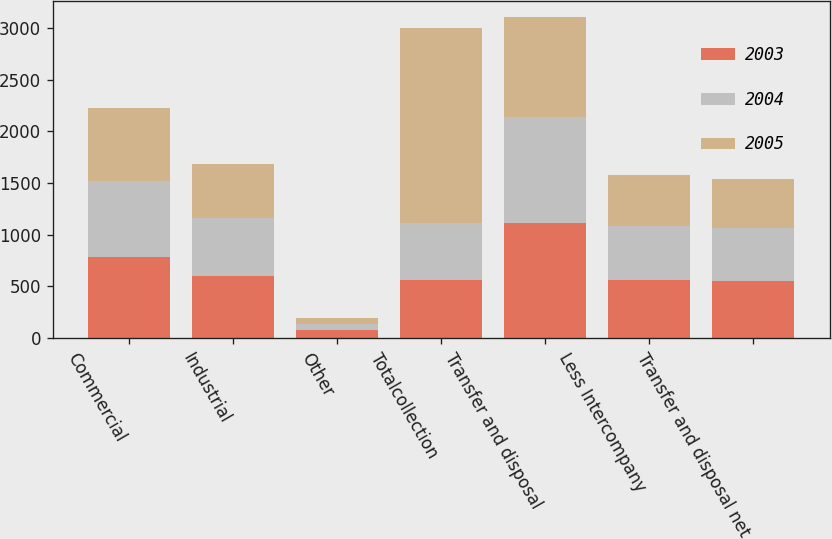Convert chart to OTSL. <chart><loc_0><loc_0><loc_500><loc_500><stacked_bar_chart><ecel><fcel>Commercial<fcel>Industrial<fcel>Other<fcel>Totalcollection<fcel>Transfer and disposal<fcel>Less Intercompany<fcel>Transfer and disposal net<nl><fcel>2003<fcel>781.1<fcel>597.8<fcel>76.6<fcel>558.1<fcel>1108.6<fcel>560.1<fcel>548.5<nl><fcel>2004<fcel>737.9<fcel>558.1<fcel>62.2<fcel>558.1<fcel>1031<fcel>519.8<fcel>511.2<nl><fcel>2005<fcel>706<fcel>523<fcel>50.9<fcel>1881.1<fcel>967.5<fcel>493.7<fcel>473.8<nl></chart> 